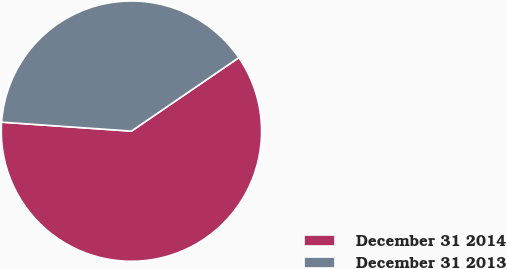Convert chart to OTSL. <chart><loc_0><loc_0><loc_500><loc_500><pie_chart><fcel>December 31 2014<fcel>December 31 2013<nl><fcel>60.65%<fcel>39.35%<nl></chart> 